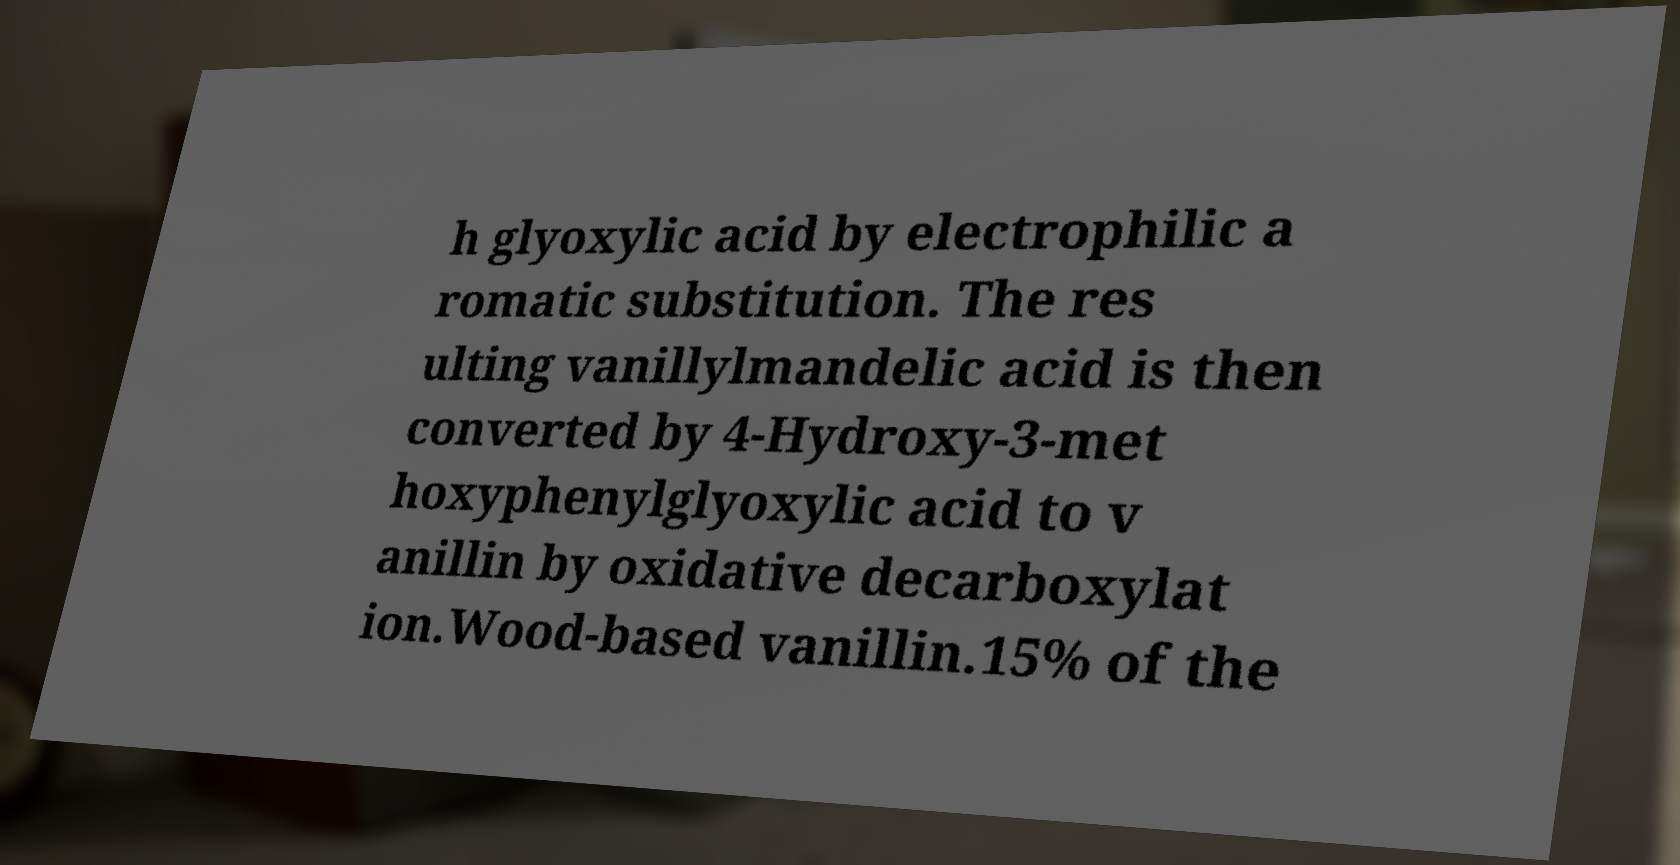Could you extract and type out the text from this image? h glyoxylic acid by electrophilic a romatic substitution. The res ulting vanillylmandelic acid is then converted by 4-Hydroxy-3-met hoxyphenylglyoxylic acid to v anillin by oxidative decarboxylat ion.Wood-based vanillin.15% of the 